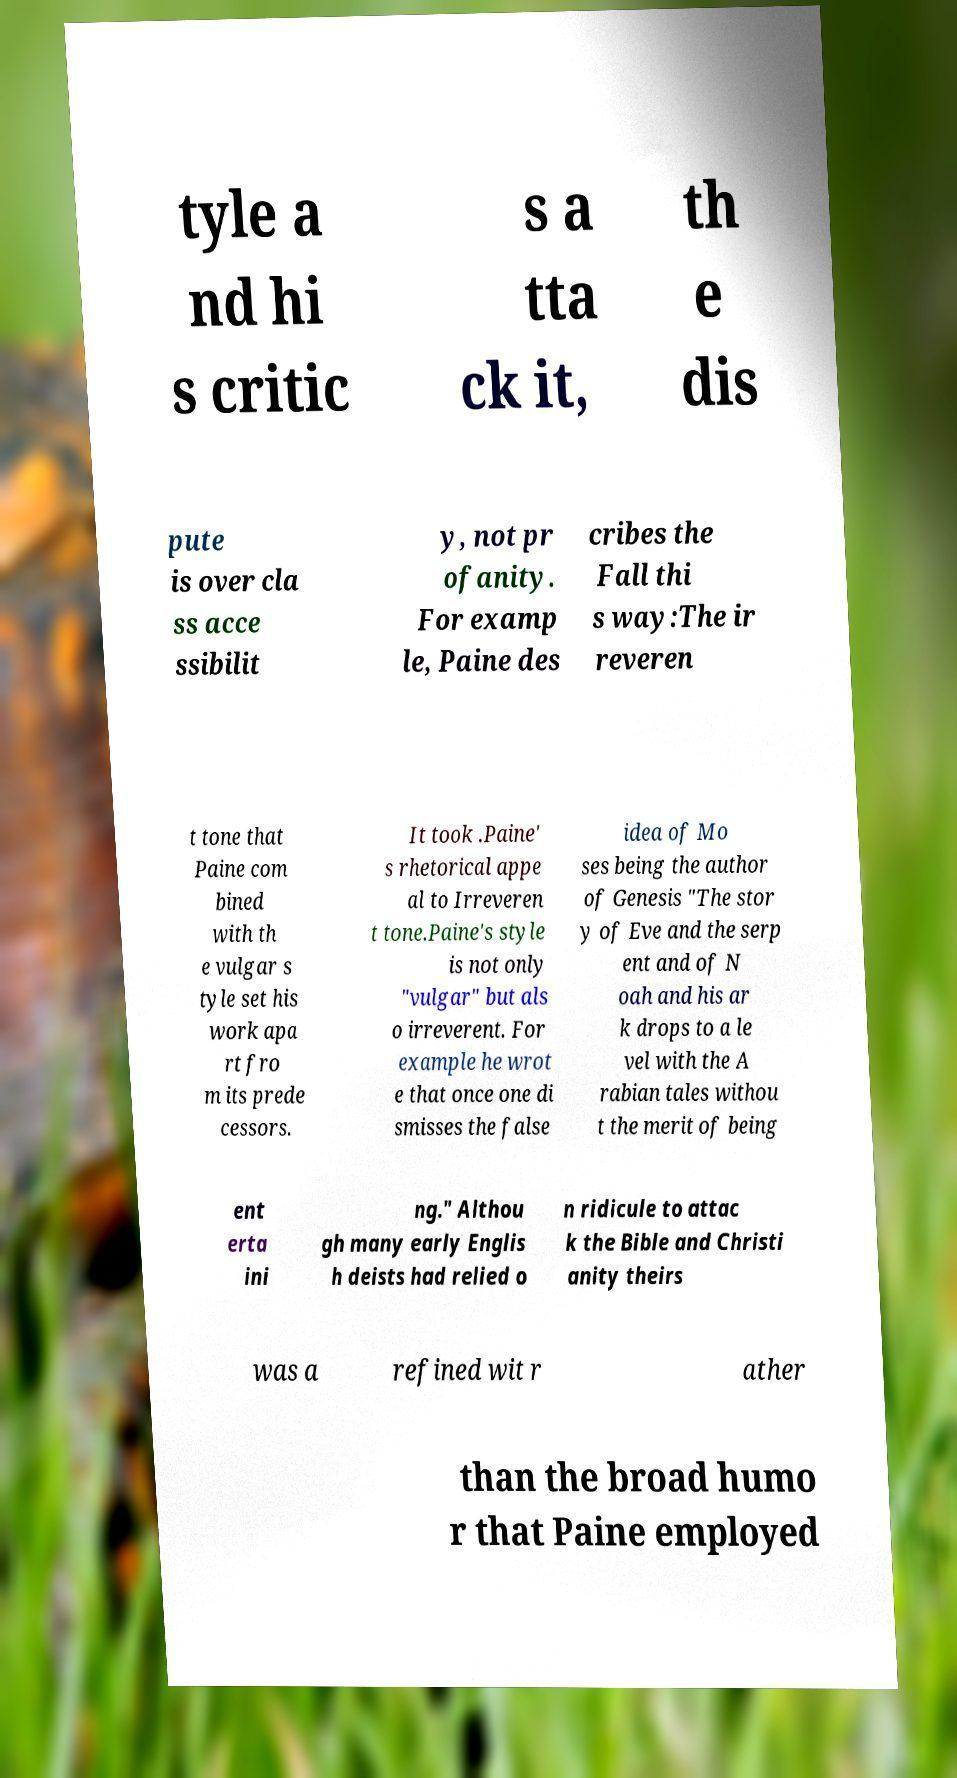Please read and relay the text visible in this image. What does it say? tyle a nd hi s critic s a tta ck it, th e dis pute is over cla ss acce ssibilit y, not pr ofanity. For examp le, Paine des cribes the Fall thi s way:The ir reveren t tone that Paine com bined with th e vulgar s tyle set his work apa rt fro m its prede cessors. It took .Paine' s rhetorical appe al to Irreveren t tone.Paine's style is not only "vulgar" but als o irreverent. For example he wrot e that once one di smisses the false idea of Mo ses being the author of Genesis "The stor y of Eve and the serp ent and of N oah and his ar k drops to a le vel with the A rabian tales withou t the merit of being ent erta ini ng." Althou gh many early Englis h deists had relied o n ridicule to attac k the Bible and Christi anity theirs was a refined wit r ather than the broad humo r that Paine employed 